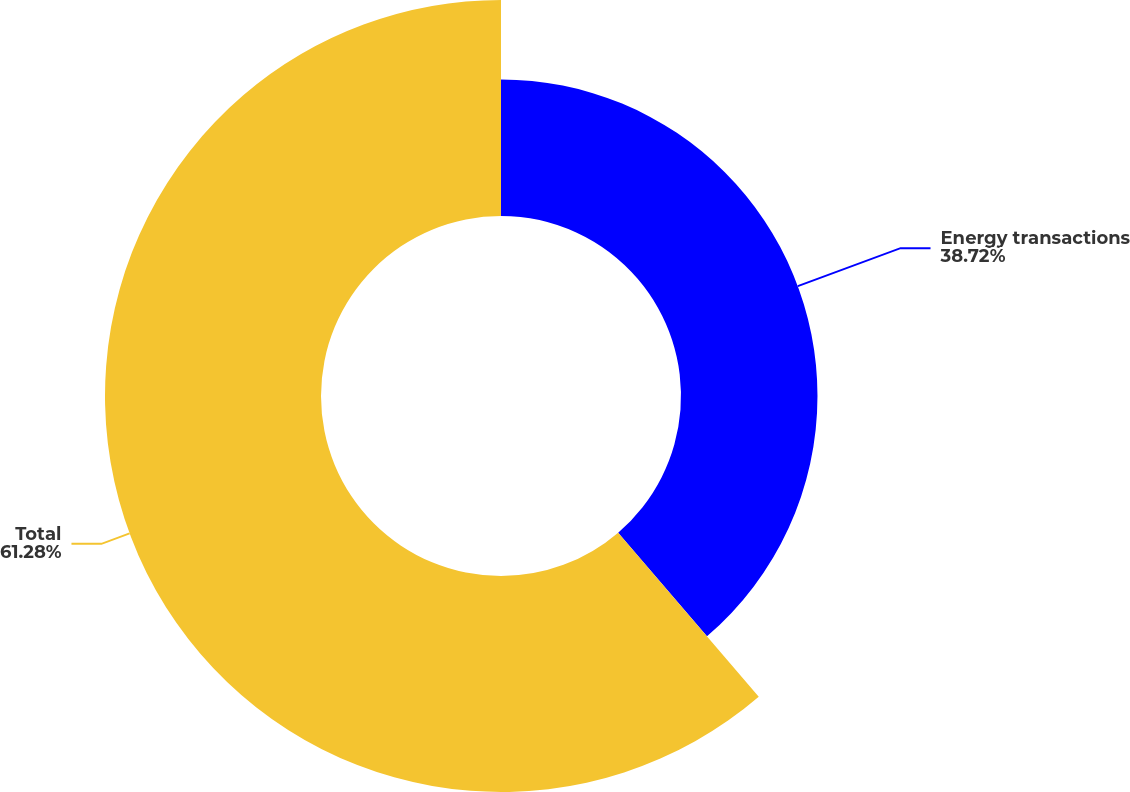<chart> <loc_0><loc_0><loc_500><loc_500><pie_chart><fcel>Energy transactions<fcel>Total<nl><fcel>38.72%<fcel>61.28%<nl></chart> 